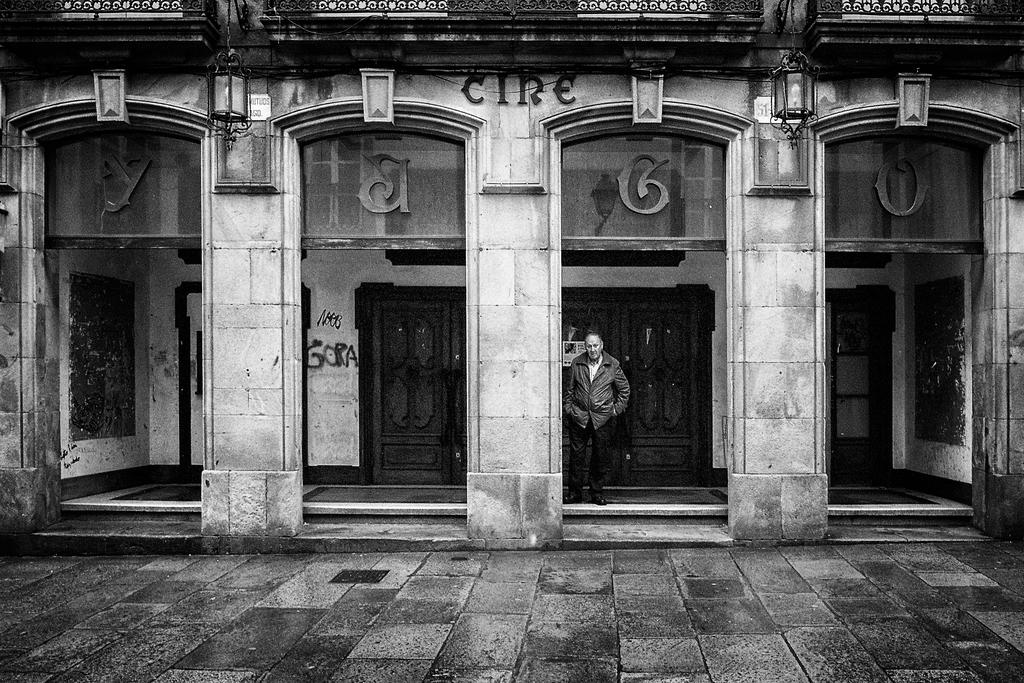What is the main structure in the image? There is a building in the image. Can you describe any people in the image? There is a man standing in the image. What feature of the building is visible in the image? There are doors visible in the image. What type of fish can be seen swimming in the building in the image? There is no fish present in the image; it features a building and a man standing nearby. 